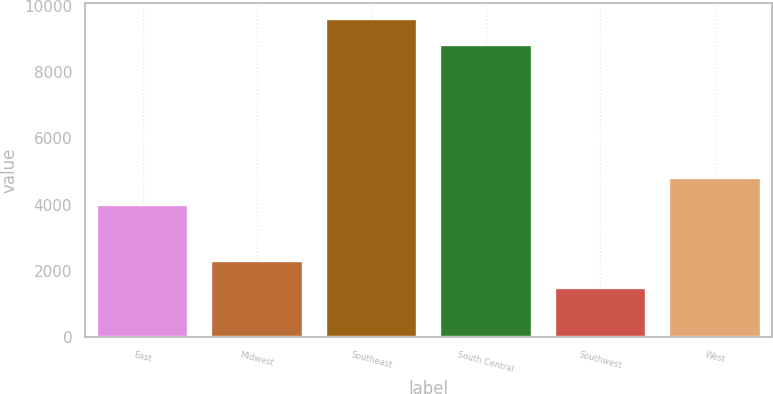<chart> <loc_0><loc_0><loc_500><loc_500><bar_chart><fcel>East<fcel>Midwest<fcel>Southeast<fcel>South Central<fcel>Southwest<fcel>West<nl><fcel>4000<fcel>2300<fcel>9600<fcel>8800<fcel>1500<fcel>4800<nl></chart> 